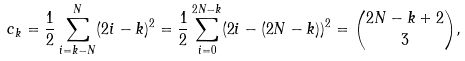Convert formula to latex. <formula><loc_0><loc_0><loc_500><loc_500>c _ { k } = \frac { 1 } { 2 } \sum _ { i = k - N } ^ { N } ( 2 i - k ) ^ { 2 } = \frac { 1 } { 2 } \sum _ { i = 0 } ^ { 2 N - k } ( 2 i - ( 2 N - k ) ) ^ { 2 } = { 2 N - k + 2 \choose 3 } ,</formula> 